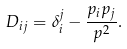Convert formula to latex. <formula><loc_0><loc_0><loc_500><loc_500>D _ { i j } = \delta _ { i } ^ { j } - \frac { p _ { i } p _ { j } } { p ^ { 2 } } .</formula> 